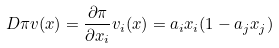<formula> <loc_0><loc_0><loc_500><loc_500>D \pi v ( x ) = \frac { \partial \pi } { \partial x _ { i } } v _ { i } ( x ) = a _ { i } x _ { i } ( 1 - a _ { j } x _ { j } )</formula> 